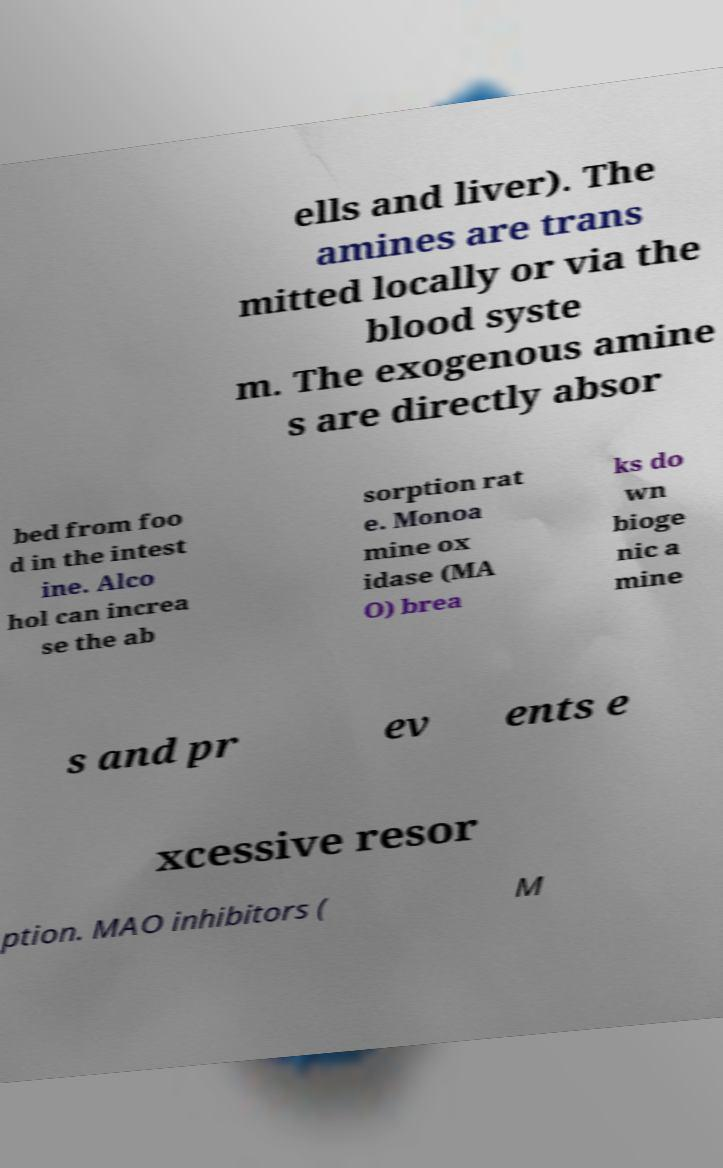Could you extract and type out the text from this image? ells and liver). The amines are trans mitted locally or via the blood syste m. The exogenous amine s are directly absor bed from foo d in the intest ine. Alco hol can increa se the ab sorption rat e. Monoa mine ox idase (MA O) brea ks do wn bioge nic a mine s and pr ev ents e xcessive resor ption. MAO inhibitors ( M 